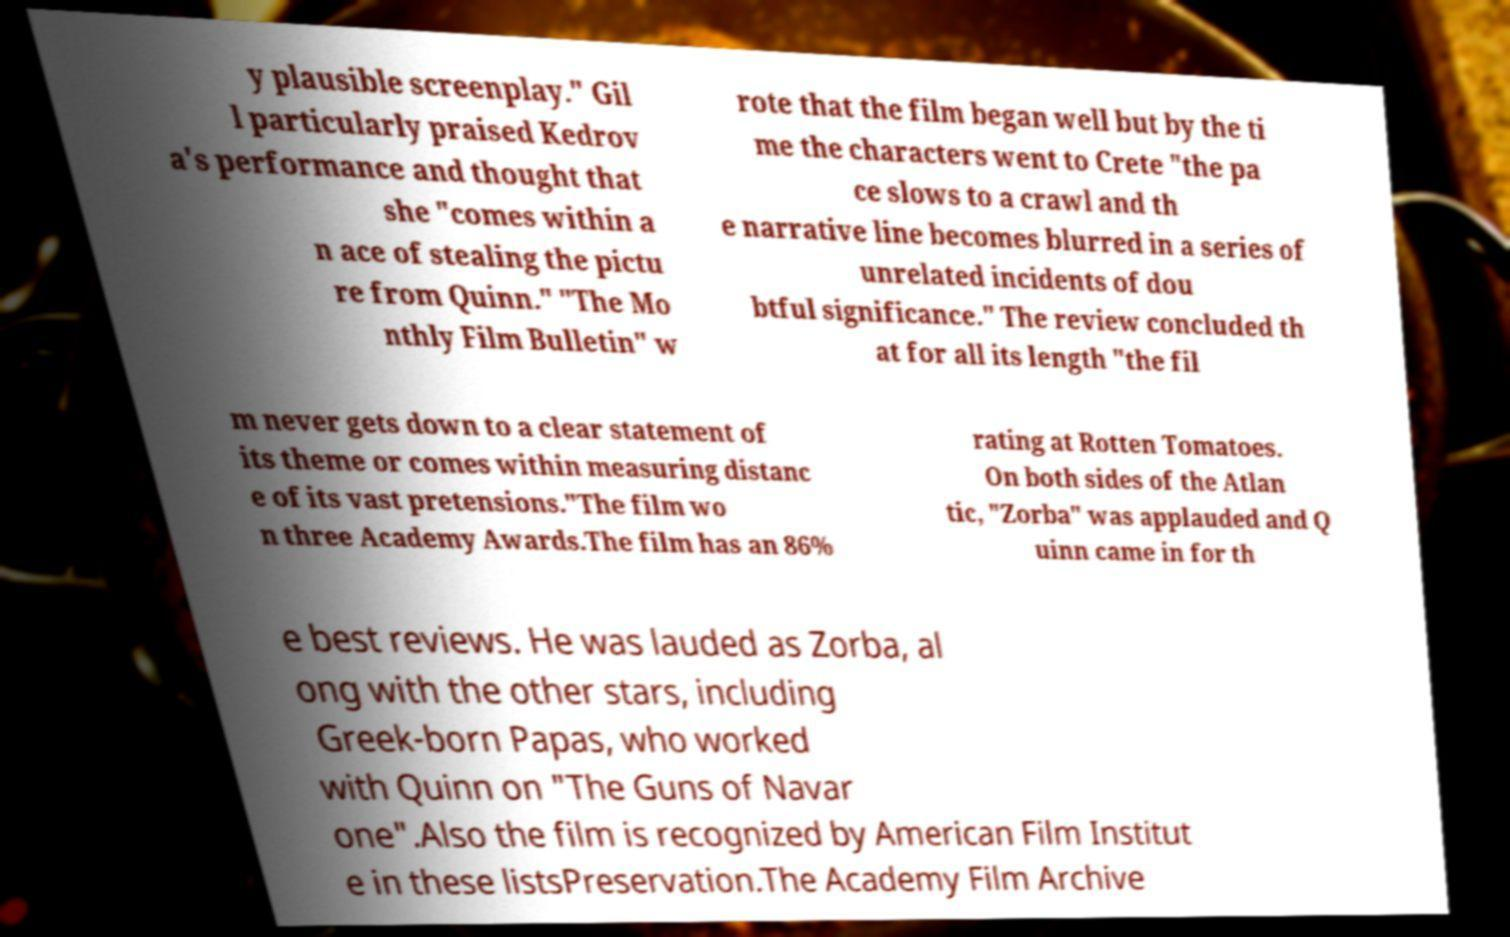Could you extract and type out the text from this image? y plausible screenplay." Gil l particularly praised Kedrov a's performance and thought that she "comes within a n ace of stealing the pictu re from Quinn." "The Mo nthly Film Bulletin" w rote that the film began well but by the ti me the characters went to Crete "the pa ce slows to a crawl and th e narrative line becomes blurred in a series of unrelated incidents of dou btful significance." The review concluded th at for all its length "the fil m never gets down to a clear statement of its theme or comes within measuring distanc e of its vast pretensions."The film wo n three Academy Awards.The film has an 86% rating at Rotten Tomatoes. On both sides of the Atlan tic, "Zorba" was applauded and Q uinn came in for th e best reviews. He was lauded as Zorba, al ong with the other stars, including Greek-born Papas, who worked with Quinn on "The Guns of Navar one".Also the film is recognized by American Film Institut e in these listsPreservation.The Academy Film Archive 